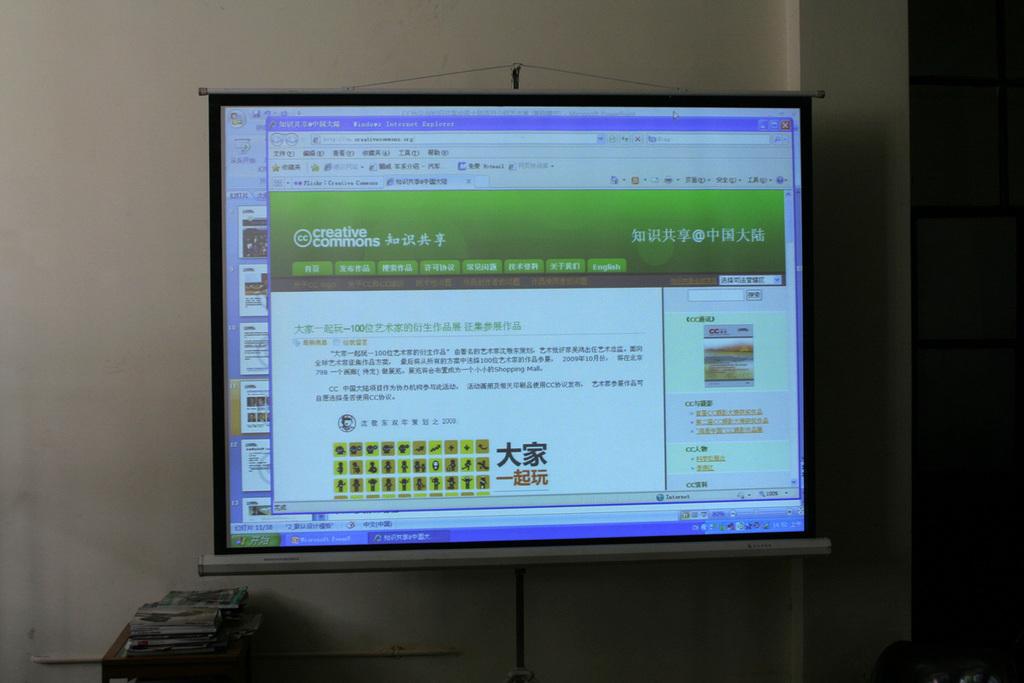This is creative what?
Offer a very short reply. Commons. What webpage browser is being used?
Make the answer very short. Unanswerable. 